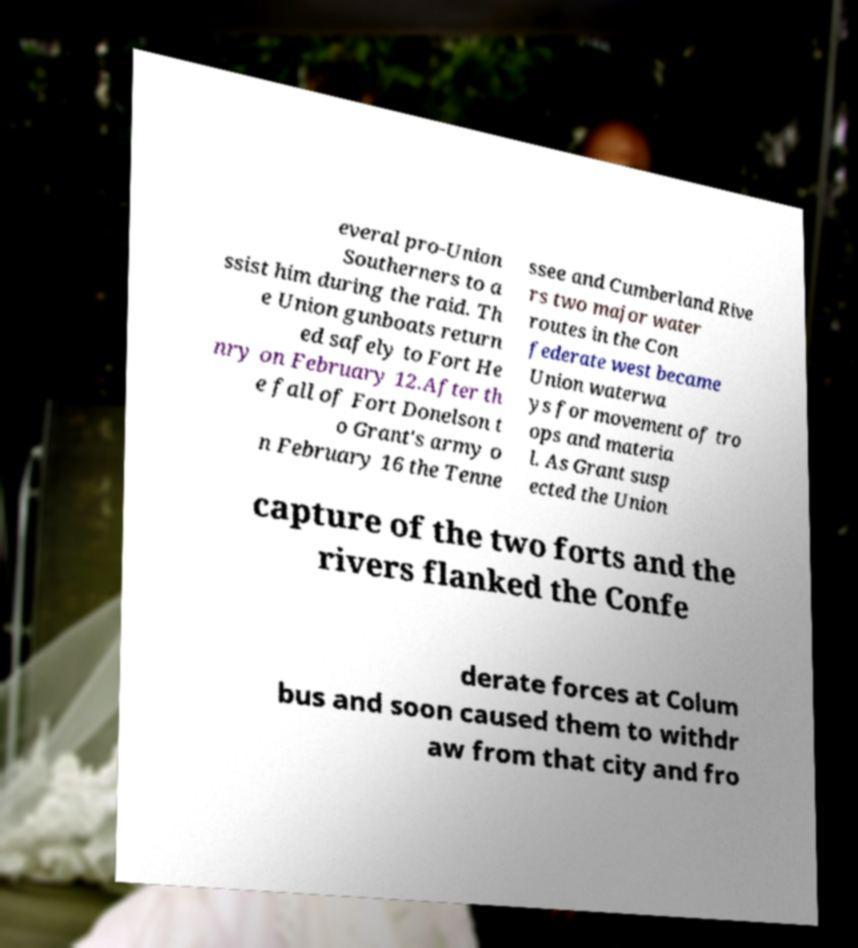There's text embedded in this image that I need extracted. Can you transcribe it verbatim? everal pro-Union Southerners to a ssist him during the raid. Th e Union gunboats return ed safely to Fort He nry on February 12.After th e fall of Fort Donelson t o Grant's army o n February 16 the Tenne ssee and Cumberland Rive rs two major water routes in the Con federate west became Union waterwa ys for movement of tro ops and materia l. As Grant susp ected the Union capture of the two forts and the rivers flanked the Confe derate forces at Colum bus and soon caused them to withdr aw from that city and fro 